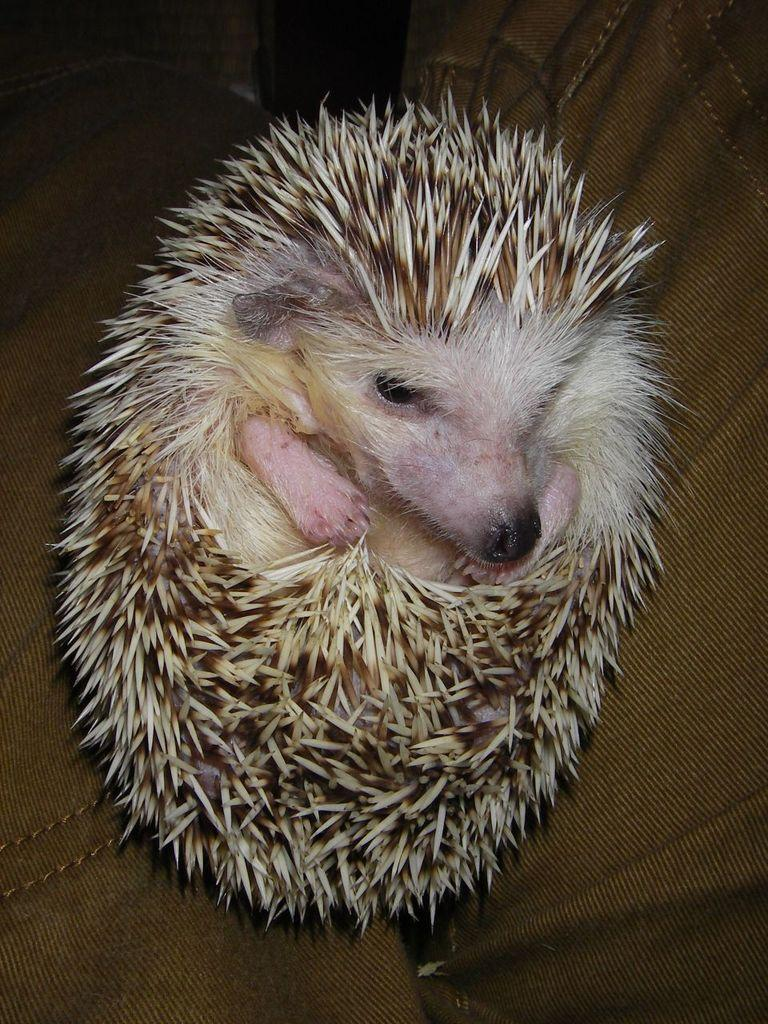What type of animal is in the image? There is a porcupine in the image. What is the porcupine sitting on in the image? The porcupine is on a brown seat. Is the girl sitting next to the porcupine in the image? There is no girl present in the image; it only features a porcupine on a brown seat. 